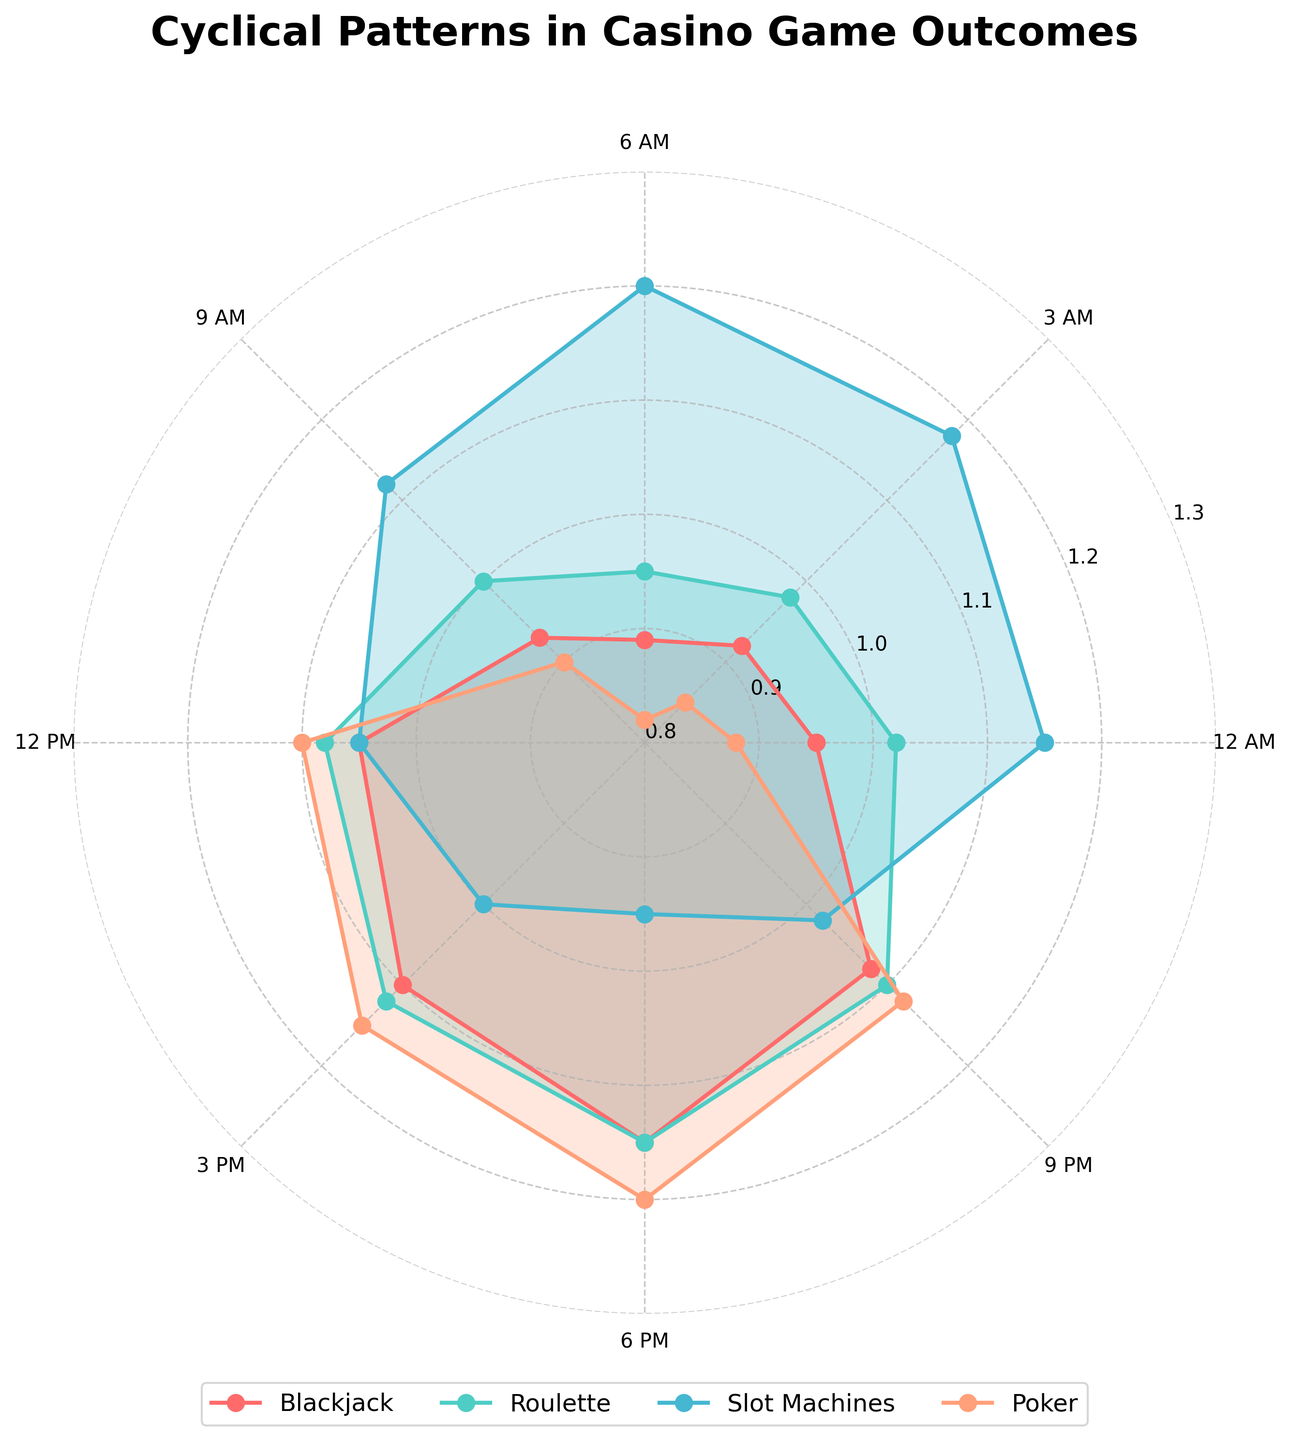What is the title of the polar chart? The title of a chart is typically placed above or within the chart. In this case, the title is written at the top of the polar chart, indicating what the chart is about.
Answer: Cyclical Patterns in Casino Game Outcomes What colors are used to represent the different casino games? The colors represent different games, indicated by the legend. Each game is associated with a specific color: red for Blackjack, teal for Roulette, light blue for Slot Machines, and peach for Poker.
Answer: Red, teal, light blue, peach Which casino game peaks at 3 PM (15:00 hours)? Observe the points at 3 PM on the chart. Each game's performance is shown with a specific color. The highest value at 3 PM belongs to Poker.
Answer: Poker What is the minimum value for Slot Machines and at what hour does it occur? Look at the polar chart, focusing on Slot Machines (light blue). The lowest value is at 6 PM with the value of 0.95.
Answer: 0.95 at 6 PM During which hour does Roulette have its peak value? Find where the line for Roulette (teal) reaches its highest point. The peak value is at 9 PM (21:00 hours).
Answer: 9 PM What is the average value of Poker outcomes over the 24-hour period? Add up all the Poker values and divide by the number of values (8). The sum is (0.88 + 0.85 + 0.82 + 0.90 + 1.10 + 1.15 + 1.20 + 1.12) = 8.02. Dividing by 8 gives 1.0025.
Answer: 1.0025 How does the Blackjack value at 12 PM compare to its value at 6 AM? Check the Blackjack values at both 12 PM and 6 AM. At 12 PM, it is 1.05, and at 6 AM, it is 0.89. Comparing them shows that the 12 PM value is higher.
Answer: 12 PM is higher Which game has the smallest fluctuation in outcomes over the observed hours? Calculate the difference between the maximum and minimum values for each game. Blackjack goes from 0.89 to 1.15, Roulette from 0.95 to 1.15, Slot Machines from 0.95 to 1.20, and Poker from 0.82 to 1.20. The smallest range is for Roulette, with a range of 0.20.
Answer: Roulette What is the value of Blackjack at midnight (12 AM) and how does it compare to the value at 6 PM? Find the values at 12 AM and 6 PM in the Blackjack dataset. At 12 AM, the value is 0.95, and at 6 PM, it is 1.15. The value is higher at 6 PM.
Answer: 6 PM is higher 